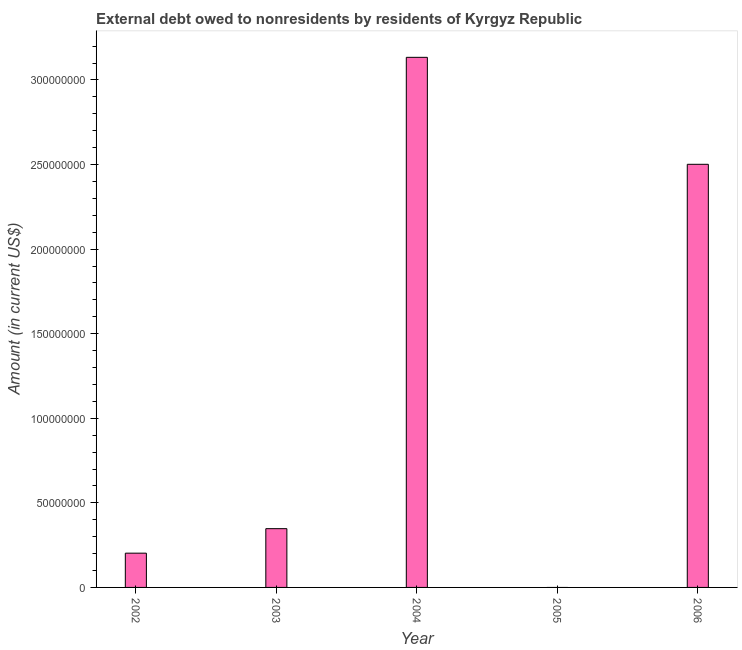Does the graph contain grids?
Provide a short and direct response. No. What is the title of the graph?
Your answer should be very brief. External debt owed to nonresidents by residents of Kyrgyz Republic. What is the label or title of the Y-axis?
Offer a terse response. Amount (in current US$). What is the debt in 2002?
Make the answer very short. 2.03e+07. Across all years, what is the maximum debt?
Your answer should be very brief. 3.13e+08. What is the sum of the debt?
Make the answer very short. 6.18e+08. What is the difference between the debt in 2003 and 2004?
Your answer should be very brief. -2.79e+08. What is the average debt per year?
Give a very brief answer. 1.24e+08. What is the median debt?
Provide a short and direct response. 3.47e+07. What is the ratio of the debt in 2004 to that in 2006?
Offer a terse response. 1.25. Is the debt in 2002 less than that in 2006?
Provide a short and direct response. Yes. Is the difference between the debt in 2004 and 2006 greater than the difference between any two years?
Your answer should be compact. No. What is the difference between the highest and the second highest debt?
Your answer should be very brief. 6.32e+07. Is the sum of the debt in 2003 and 2004 greater than the maximum debt across all years?
Your response must be concise. Yes. What is the difference between the highest and the lowest debt?
Offer a terse response. 3.13e+08. In how many years, is the debt greater than the average debt taken over all years?
Ensure brevity in your answer.  2. How many bars are there?
Your answer should be very brief. 4. Are all the bars in the graph horizontal?
Keep it short and to the point. No. What is the difference between two consecutive major ticks on the Y-axis?
Offer a terse response. 5.00e+07. Are the values on the major ticks of Y-axis written in scientific E-notation?
Your response must be concise. No. What is the Amount (in current US$) of 2002?
Offer a terse response. 2.03e+07. What is the Amount (in current US$) in 2003?
Your response must be concise. 3.47e+07. What is the Amount (in current US$) of 2004?
Give a very brief answer. 3.13e+08. What is the Amount (in current US$) of 2006?
Provide a short and direct response. 2.50e+08. What is the difference between the Amount (in current US$) in 2002 and 2003?
Keep it short and to the point. -1.45e+07. What is the difference between the Amount (in current US$) in 2002 and 2004?
Your answer should be very brief. -2.93e+08. What is the difference between the Amount (in current US$) in 2002 and 2006?
Provide a short and direct response. -2.30e+08. What is the difference between the Amount (in current US$) in 2003 and 2004?
Offer a very short reply. -2.79e+08. What is the difference between the Amount (in current US$) in 2003 and 2006?
Provide a succinct answer. -2.15e+08. What is the difference between the Amount (in current US$) in 2004 and 2006?
Give a very brief answer. 6.32e+07. What is the ratio of the Amount (in current US$) in 2002 to that in 2003?
Your answer should be very brief. 0.58. What is the ratio of the Amount (in current US$) in 2002 to that in 2004?
Keep it short and to the point. 0.07. What is the ratio of the Amount (in current US$) in 2002 to that in 2006?
Make the answer very short. 0.08. What is the ratio of the Amount (in current US$) in 2003 to that in 2004?
Offer a very short reply. 0.11. What is the ratio of the Amount (in current US$) in 2003 to that in 2006?
Your answer should be compact. 0.14. What is the ratio of the Amount (in current US$) in 2004 to that in 2006?
Offer a terse response. 1.25. 